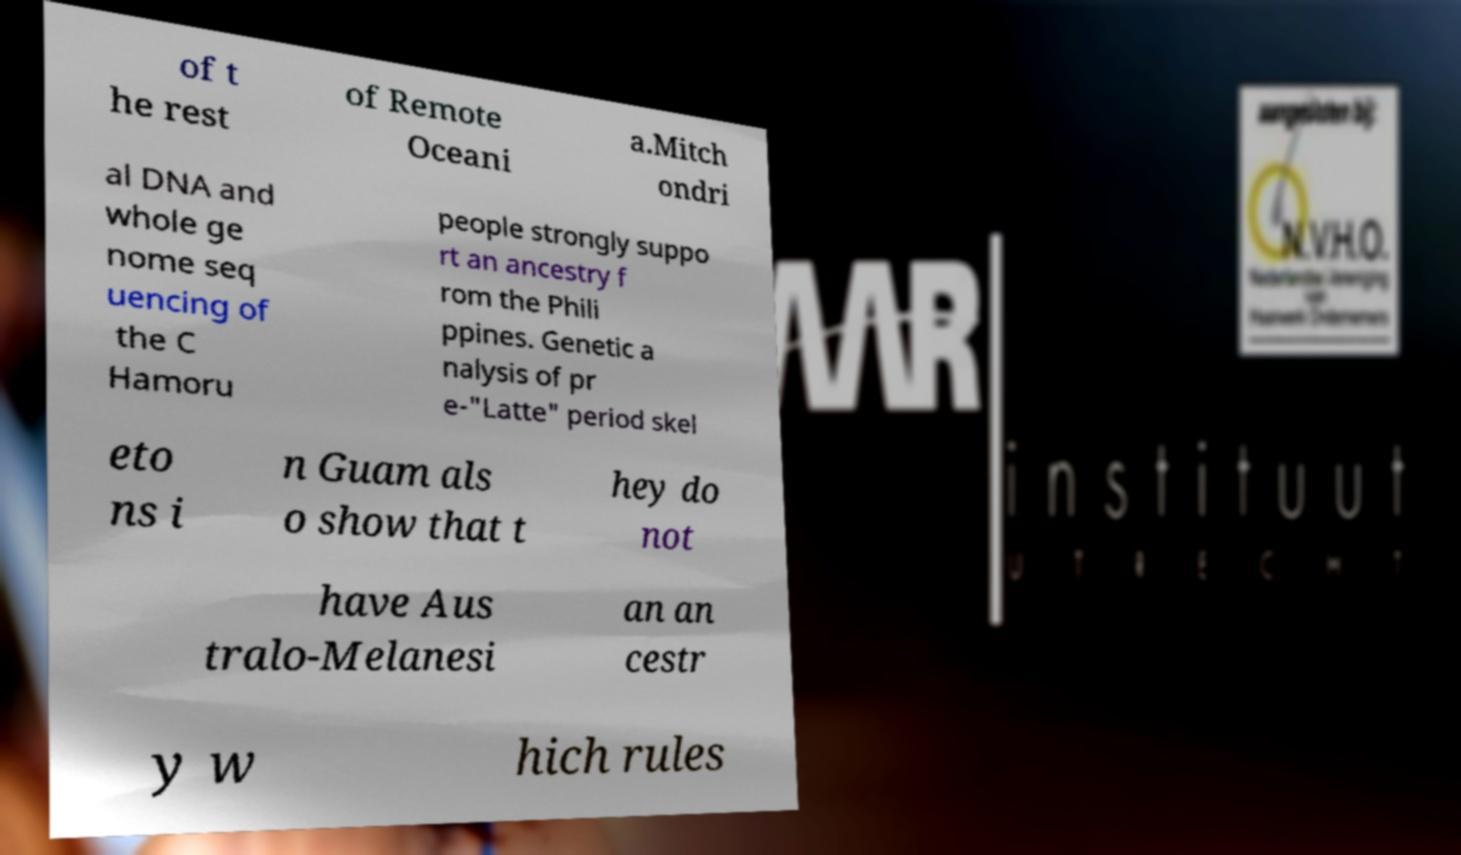I need the written content from this picture converted into text. Can you do that? of t he rest of Remote Oceani a.Mitch ondri al DNA and whole ge nome seq uencing of the C Hamoru people strongly suppo rt an ancestry f rom the Phili ppines. Genetic a nalysis of pr e-"Latte" period skel eto ns i n Guam als o show that t hey do not have Aus tralo-Melanesi an an cestr y w hich rules 